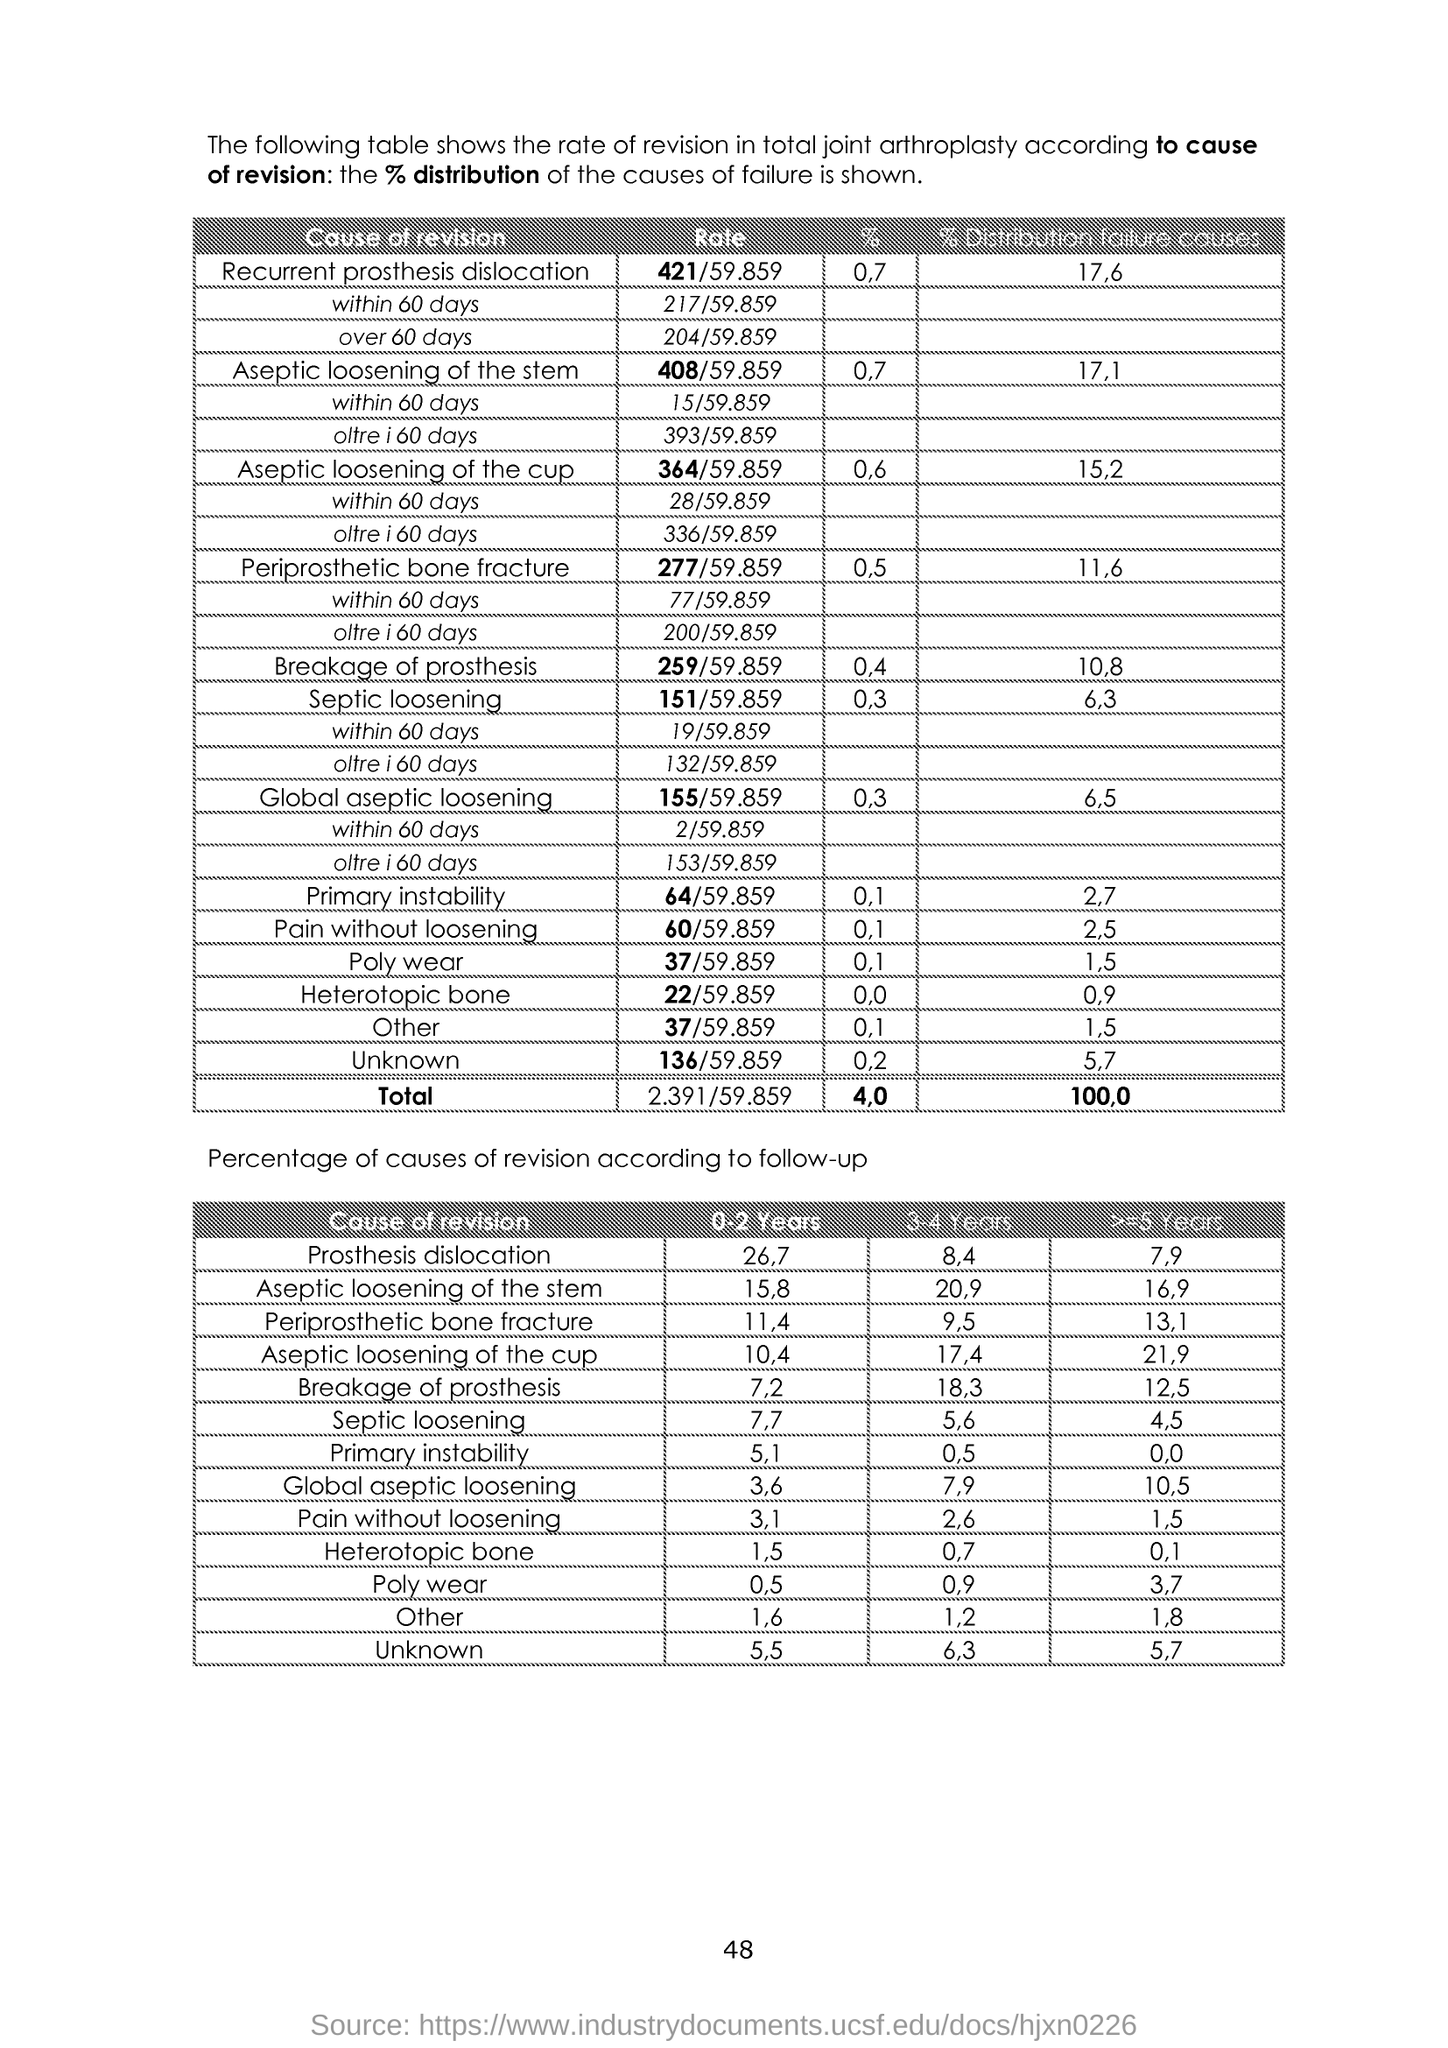Indicate a few pertinent items in this graphic. The page number is 48," the speaker declared. 